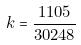Convert formula to latex. <formula><loc_0><loc_0><loc_500><loc_500>k = \frac { 1 1 0 5 } { 3 0 2 4 8 }</formula> 